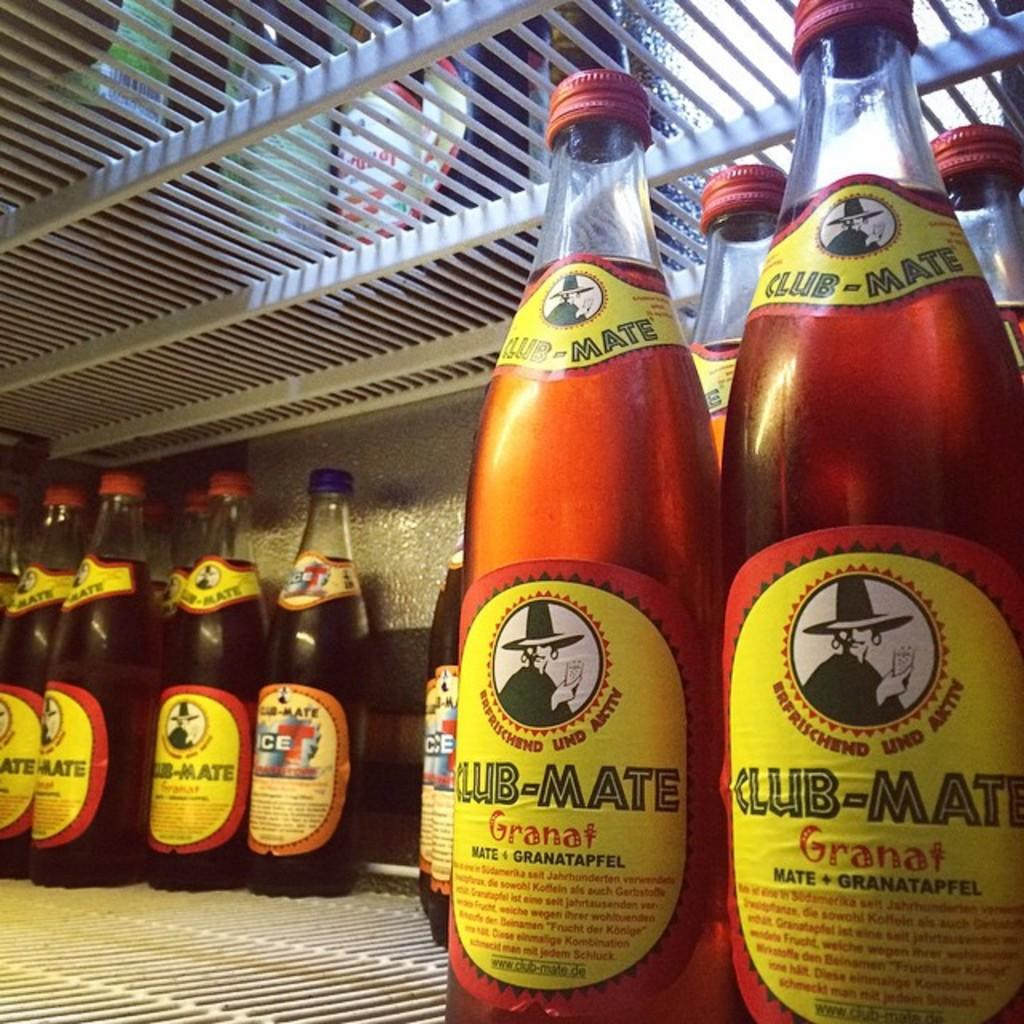<image>
Render a clear and concise summary of the photo. several Club Mate bottles on a shelf in a fridge 